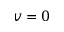<formula> <loc_0><loc_0><loc_500><loc_500>v = 0</formula> 